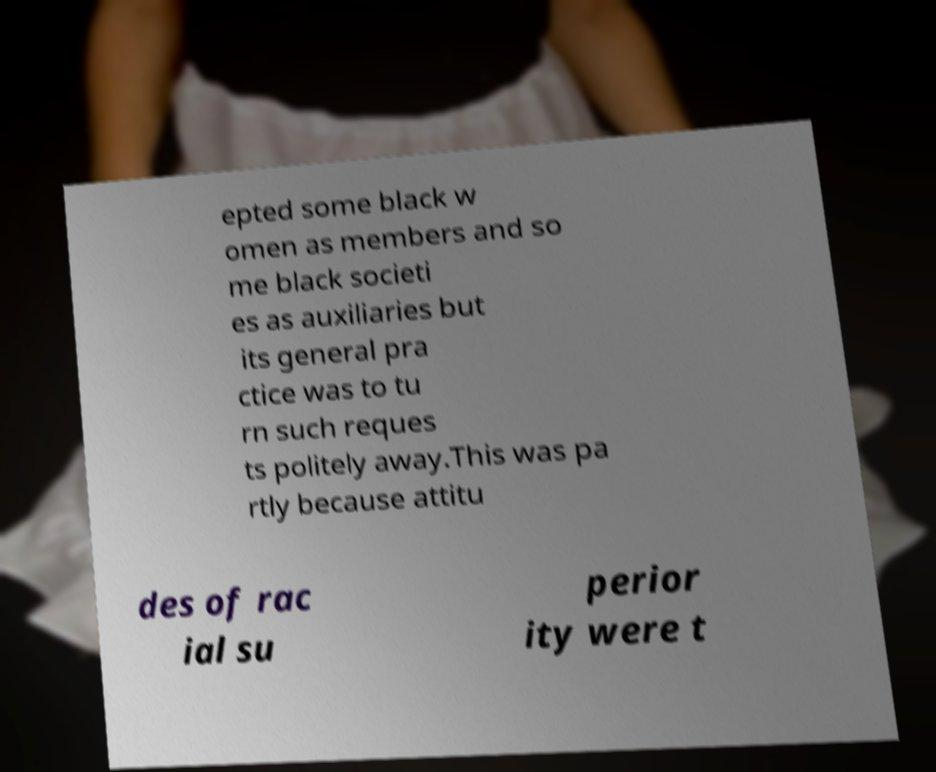Can you read and provide the text displayed in the image?This photo seems to have some interesting text. Can you extract and type it out for me? epted some black w omen as members and so me black societi es as auxiliaries but its general pra ctice was to tu rn such reques ts politely away.This was pa rtly because attitu des of rac ial su perior ity were t 